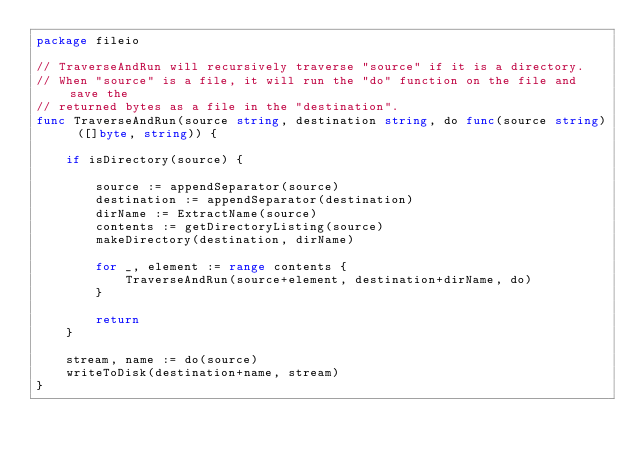<code> <loc_0><loc_0><loc_500><loc_500><_Go_>package fileio

// TraverseAndRun will recursively traverse "source" if it is a directory.
// When "source" is a file, it will run the "do" function on the file and save the
// returned bytes as a file in the "destination".
func TraverseAndRun(source string, destination string, do func(source string) ([]byte, string)) {

	if isDirectory(source) {

		source := appendSeparator(source)
		destination := appendSeparator(destination)
		dirName := ExtractName(source)
		contents := getDirectoryListing(source)
		makeDirectory(destination, dirName)

		for _, element := range contents {
			TraverseAndRun(source+element, destination+dirName, do)
		}

		return
	}

	stream, name := do(source)
	writeToDisk(destination+name, stream)
}
</code> 